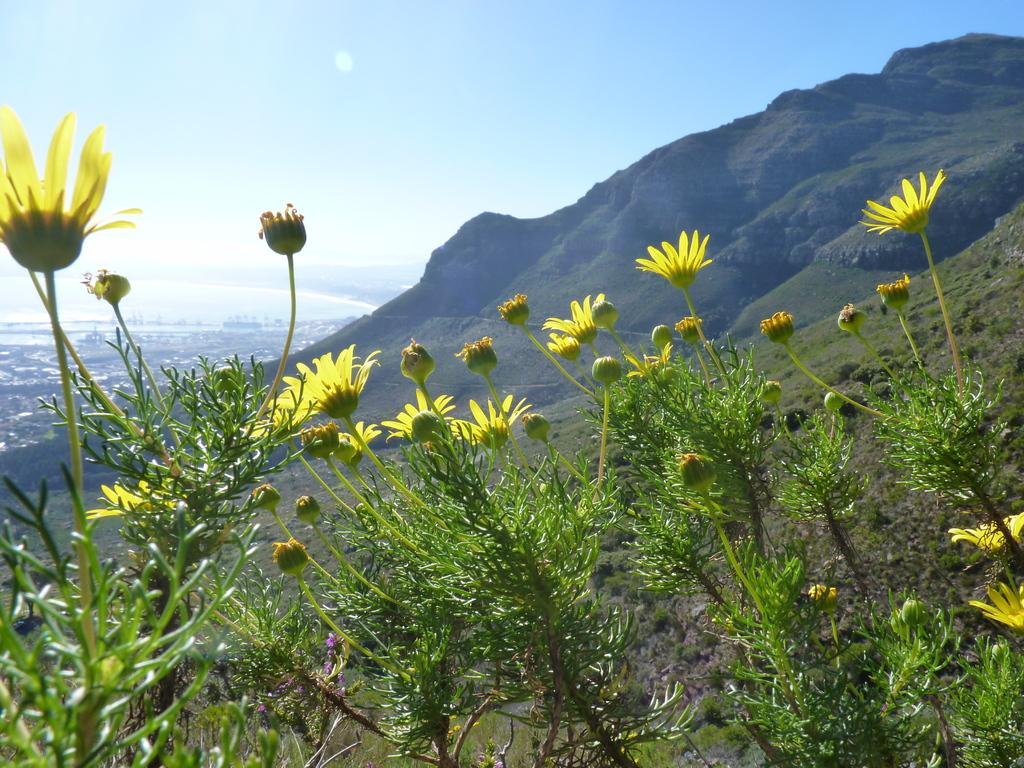What is visible in the sky in the image? The sky with clouds is visible in the image. What type of natural landforms can be seen in the image? There are hills in the image. What type of vegetation is present in the image? There are plants with flowers in the image. Where is the sidewalk located in the image? There is no sidewalk present in the image. What type of mine is visible in the image? There is no mine present in the image. 